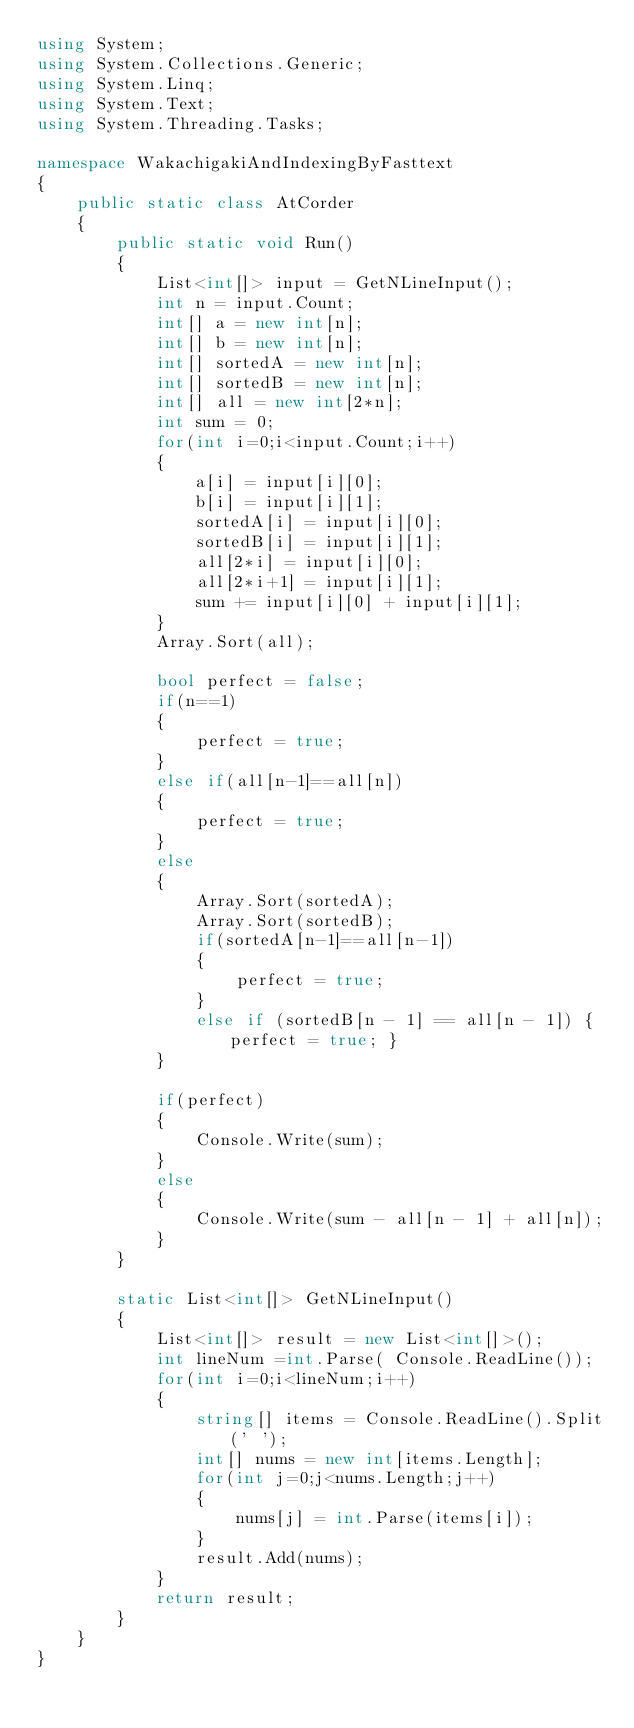Convert code to text. <code><loc_0><loc_0><loc_500><loc_500><_C#_>using System;
using System.Collections.Generic;
using System.Linq;
using System.Text;
using System.Threading.Tasks;

namespace WakachigakiAndIndexingByFasttext
{
    public static class AtCorder
    {
        public static void Run()
        {
            List<int[]> input = GetNLineInput();
            int n = input.Count;
            int[] a = new int[n];
            int[] b = new int[n];
            int[] sortedA = new int[n];
            int[] sortedB = new int[n];
            int[] all = new int[2*n];
            int sum = 0;
            for(int i=0;i<input.Count;i++)
            {
                a[i] = input[i][0];
                b[i] = input[i][1];
                sortedA[i] = input[i][0];
                sortedB[i] = input[i][1];
                all[2*i] = input[i][0];
                all[2*i+1] = input[i][1];
                sum += input[i][0] + input[i][1];
            }
            Array.Sort(all);

            bool perfect = false;
            if(n==1)
            {
                perfect = true;
            }
            else if(all[n-1]==all[n])
            {
                perfect = true;
            }
            else
            {
                Array.Sort(sortedA);
                Array.Sort(sortedB);
                if(sortedA[n-1]==all[n-1])
                {
                    perfect = true;
                }
                else if (sortedB[n - 1] == all[n - 1]) { perfect = true; }
            }

            if(perfect)
            {
                Console.Write(sum);
            }
            else
            {
                Console.Write(sum - all[n - 1] + all[n]);
            }
        }
        
        static List<int[]> GetNLineInput()
        {
            List<int[]> result = new List<int[]>();
            int lineNum =int.Parse( Console.ReadLine());
            for(int i=0;i<lineNum;i++)
            {
                string[] items = Console.ReadLine().Split(' ');
                int[] nums = new int[items.Length];
                for(int j=0;j<nums.Length;j++)
                {
                    nums[j] = int.Parse(items[i]);
                }
                result.Add(nums);
            }
            return result;
        }
    }
}</code> 